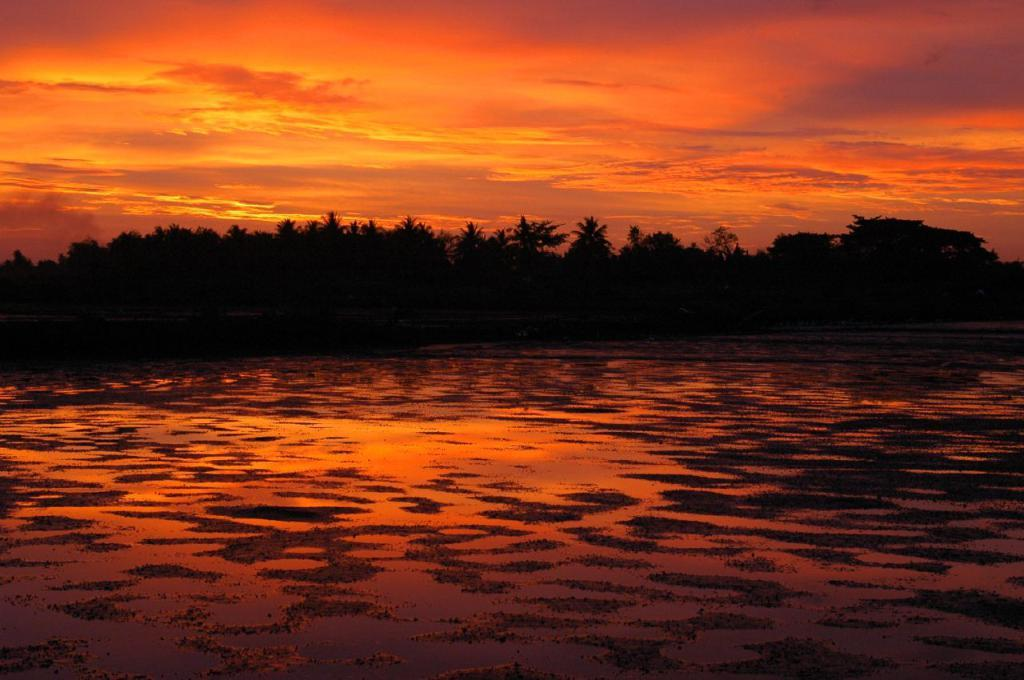What is the main feature of the image? The main feature of the image is a water surface. What can be seen in the distance beyond the water surface? Many trees are visible in the distance. What is visible above the water surface and trees? The sky is visible in the image. What can be observed in the sky? Clouds are present in the sky, and sunshine is visible. What letter is being written by the secretary in the image? There is no secretary or letter present in the image. 